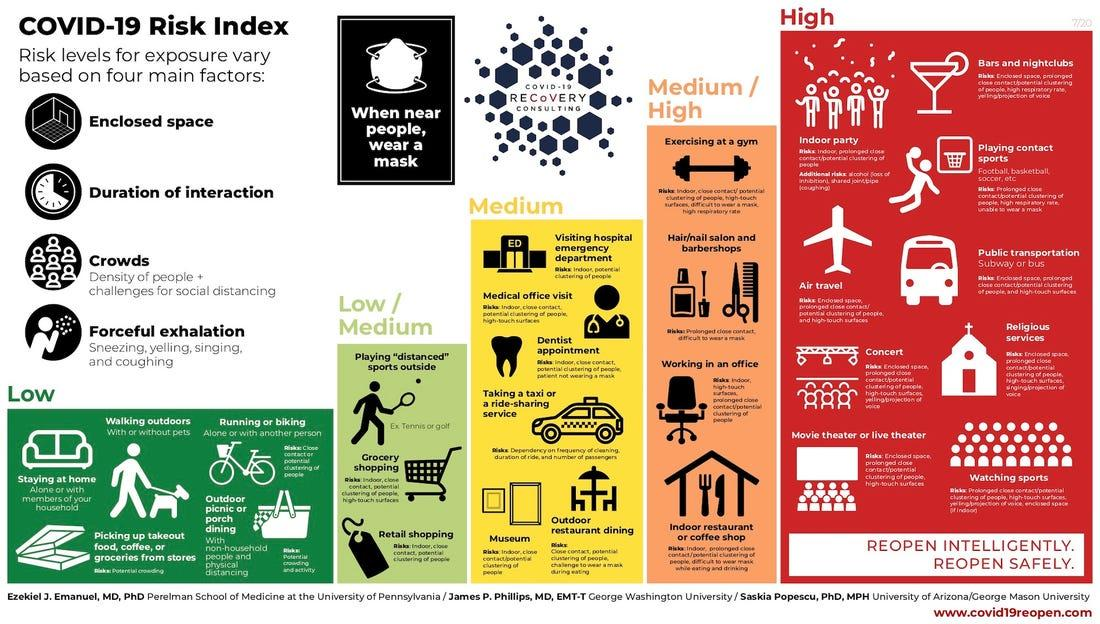Specify some key components in this picture. The color red is used to represent the high-risk category of COVID-19 in the infographic image. Indoor partying is considered a high risk activity for COVID-19, according to risk category. Grocery shopping belongs to the low risk category of COVID-19. Walking outdoors is considered to be in the low risk category of COVID-19. The color green is used to depict the low-risk category of COVID-19 in the given infographic image. 